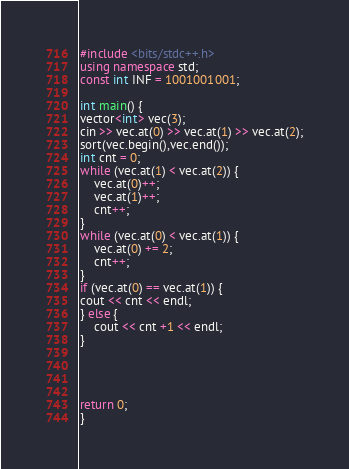Convert code to text. <code><loc_0><loc_0><loc_500><loc_500><_C++_>#include <bits/stdc++.h>
using namespace std;
const int INF = 1001001001;

int main() {
vector<int> vec(3);
cin >> vec.at(0) >> vec.at(1) >> vec.at(2);
sort(vec.begin(),vec.end());
int cnt = 0;
while (vec.at(1) < vec.at(2)) {
    vec.at(0)++;
    vec.at(1)++;
    cnt++;
}
while (vec.at(0) < vec.at(1)) {
    vec.at(0) += 2;
    cnt++;
}
if (vec.at(0) == vec.at(1)) {
cout << cnt << endl;
} else {
    cout << cnt +1 << endl;
}




return 0;
}
</code> 